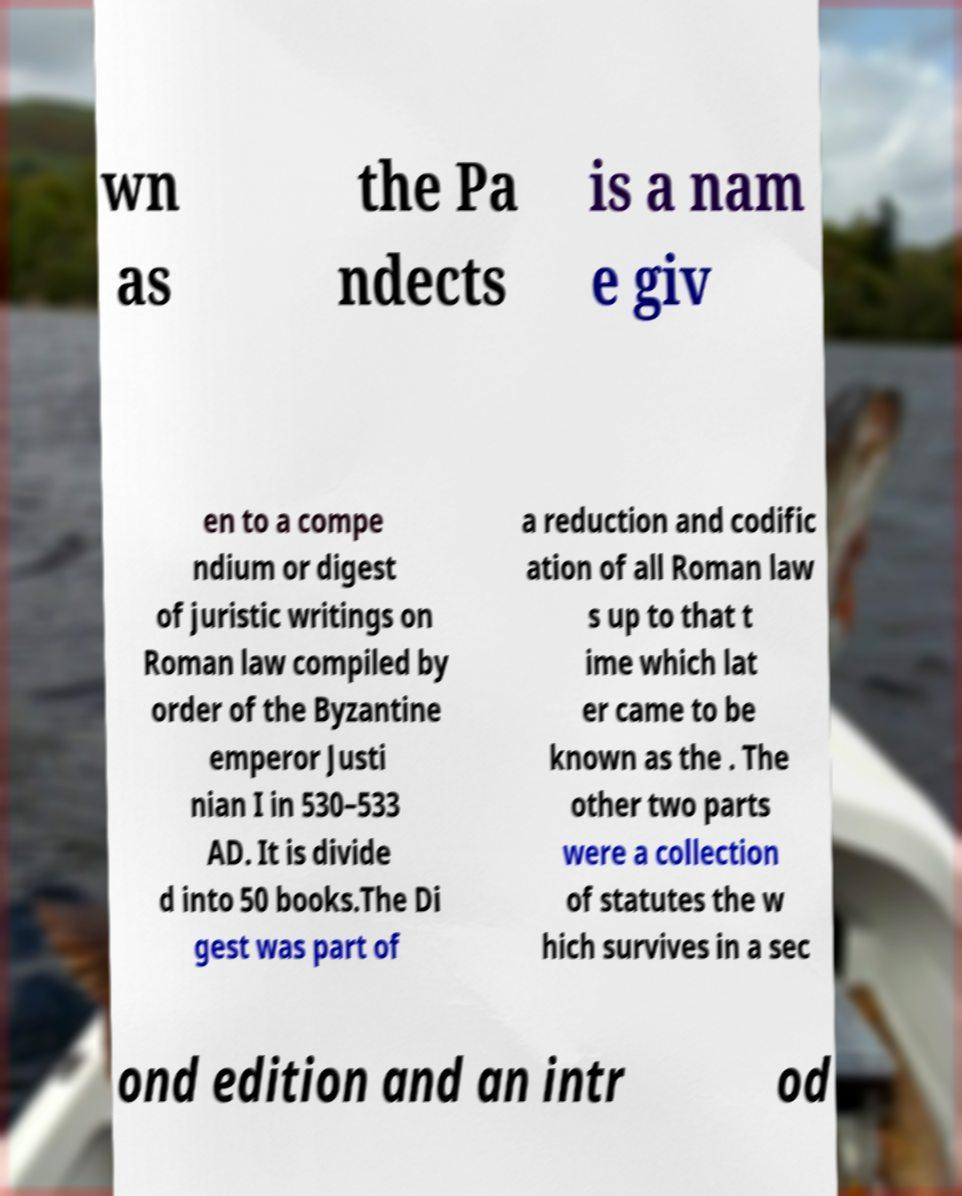For documentation purposes, I need the text within this image transcribed. Could you provide that? wn as the Pa ndects is a nam e giv en to a compe ndium or digest of juristic writings on Roman law compiled by order of the Byzantine emperor Justi nian I in 530–533 AD. It is divide d into 50 books.The Di gest was part of a reduction and codific ation of all Roman law s up to that t ime which lat er came to be known as the . The other two parts were a collection of statutes the w hich survives in a sec ond edition and an intr od 